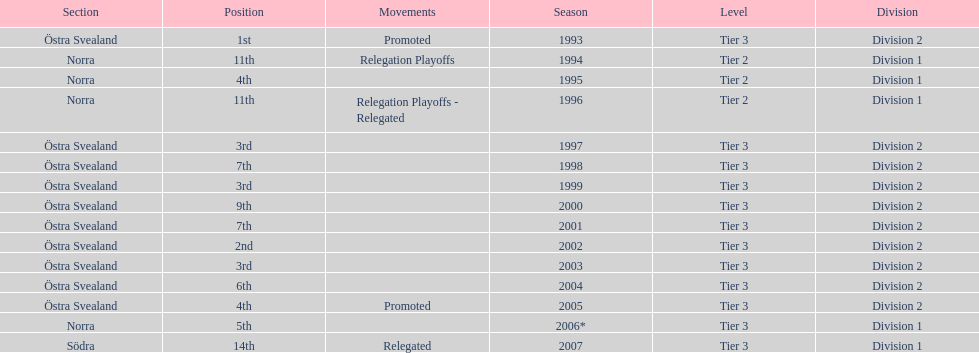What year is at least on the list? 2007. 